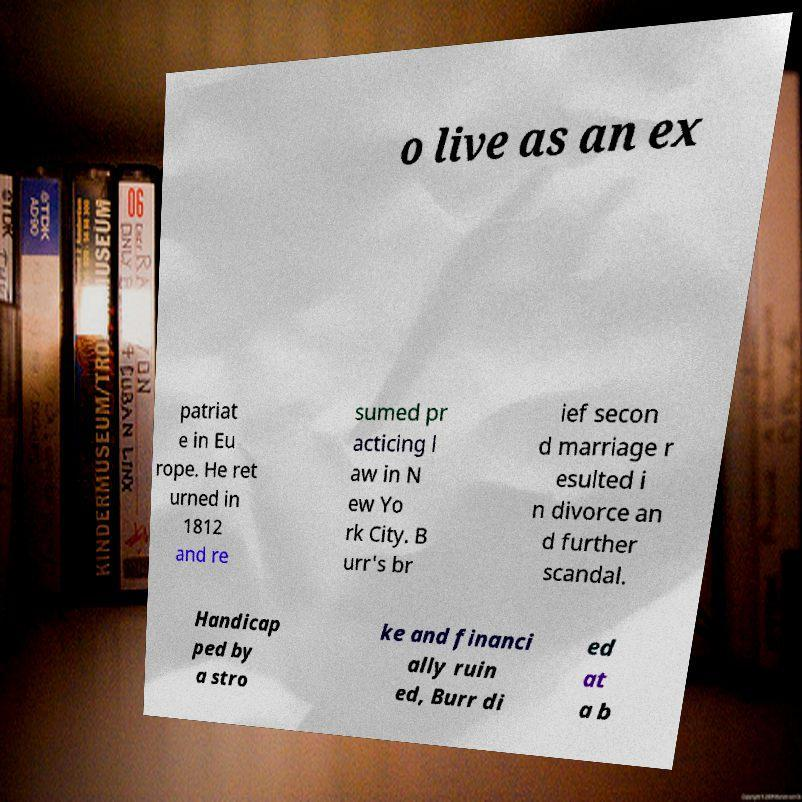Could you assist in decoding the text presented in this image and type it out clearly? o live as an ex patriat e in Eu rope. He ret urned in 1812 and re sumed pr acticing l aw in N ew Yo rk City. B urr's br ief secon d marriage r esulted i n divorce an d further scandal. Handicap ped by a stro ke and financi ally ruin ed, Burr di ed at a b 